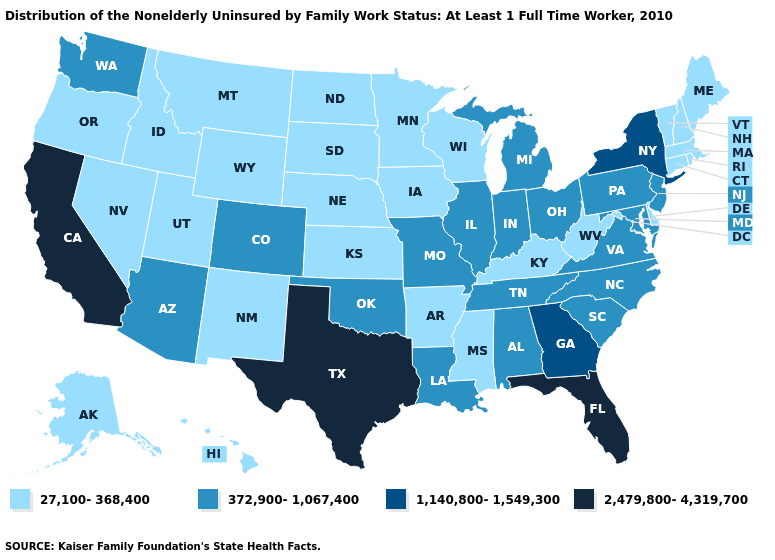Does Minnesota have the lowest value in the MidWest?
Answer briefly. Yes. Name the states that have a value in the range 1,140,800-1,549,300?
Write a very short answer. Georgia, New York. What is the highest value in the South ?
Be succinct. 2,479,800-4,319,700. Which states hav the highest value in the South?
Answer briefly. Florida, Texas. Does New York have the highest value in the Northeast?
Give a very brief answer. Yes. Among the states that border Vermont , does New Hampshire have the lowest value?
Write a very short answer. Yes. What is the value of North Dakota?
Quick response, please. 27,100-368,400. Among the states that border Kentucky , which have the lowest value?
Write a very short answer. West Virginia. Name the states that have a value in the range 372,900-1,067,400?
Short answer required. Alabama, Arizona, Colorado, Illinois, Indiana, Louisiana, Maryland, Michigan, Missouri, New Jersey, North Carolina, Ohio, Oklahoma, Pennsylvania, South Carolina, Tennessee, Virginia, Washington. Name the states that have a value in the range 1,140,800-1,549,300?
Keep it brief. Georgia, New York. Does the map have missing data?
Answer briefly. No. Does West Virginia have the same value as New Jersey?
Quick response, please. No. What is the highest value in states that border Georgia?
Answer briefly. 2,479,800-4,319,700. What is the value of Utah?
Short answer required. 27,100-368,400. What is the highest value in the USA?
Answer briefly. 2,479,800-4,319,700. 